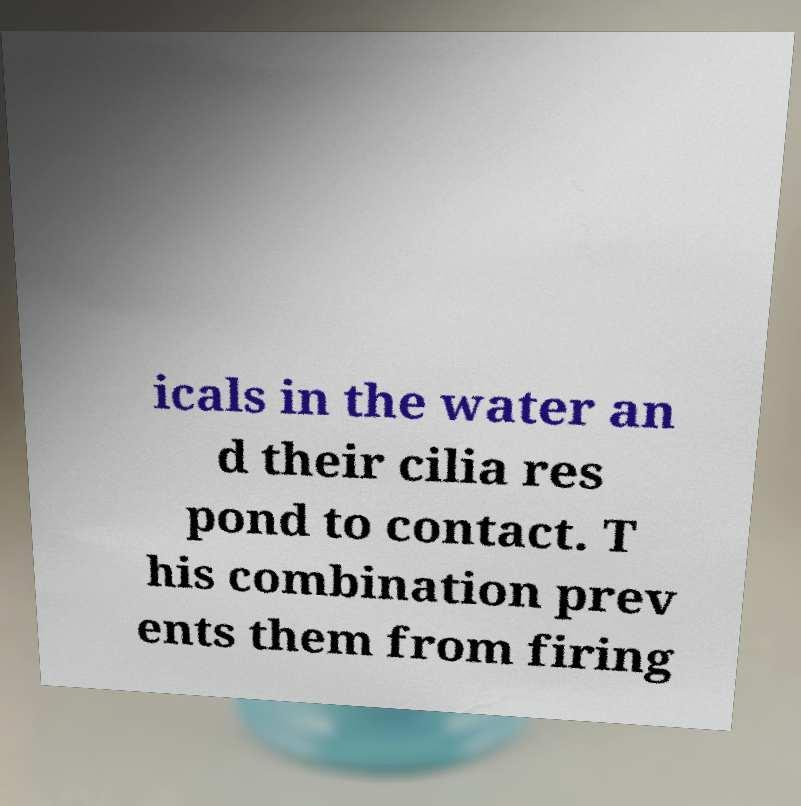Can you read and provide the text displayed in the image?This photo seems to have some interesting text. Can you extract and type it out for me? icals in the water an d their cilia res pond to contact. T his combination prev ents them from firing 